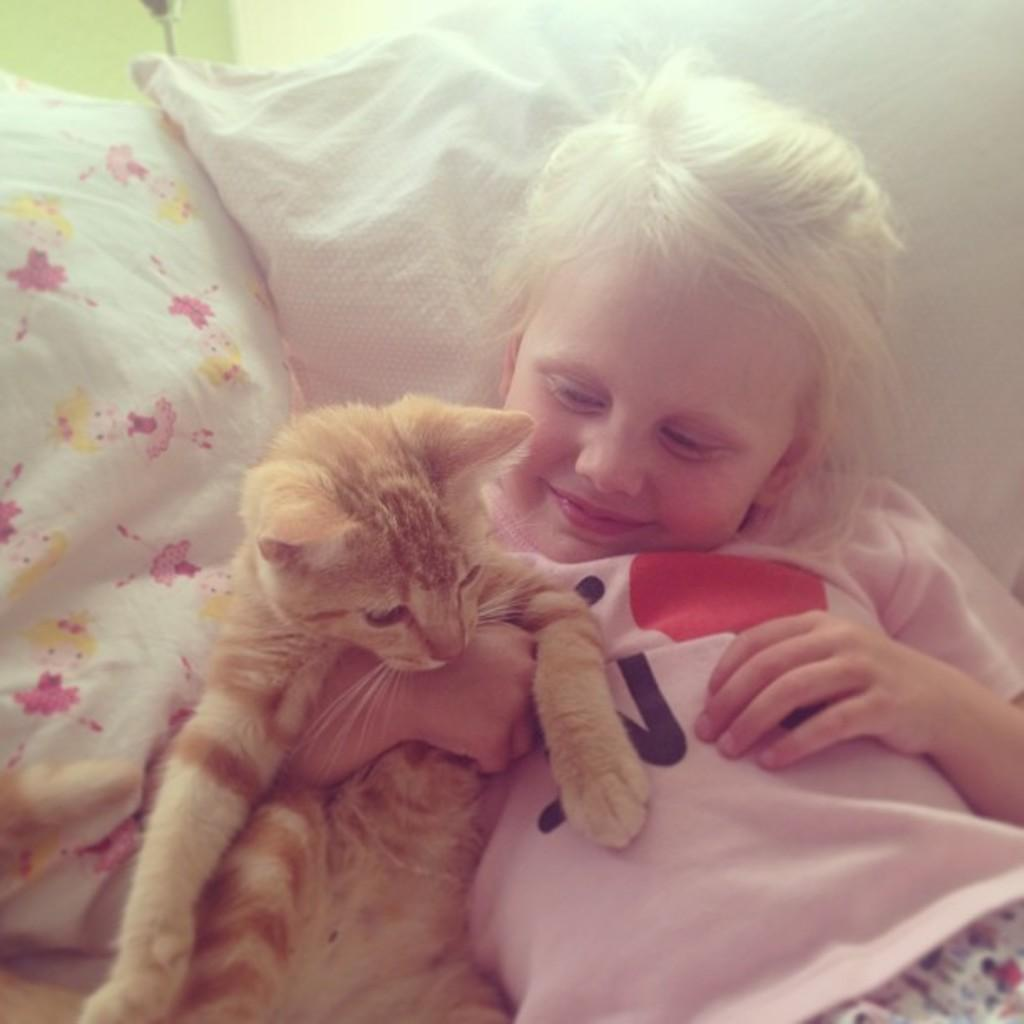Who is the main subject in the picture? There is a girl in the picture. What is the girl holding in the picture? The girl is holding a cat. What is the girl leaning on in the picture? The girl is leaning on a pillow. What type of cake is the girl baking in the picture? There is no cake present in the image, nor is the girl baking anything. 